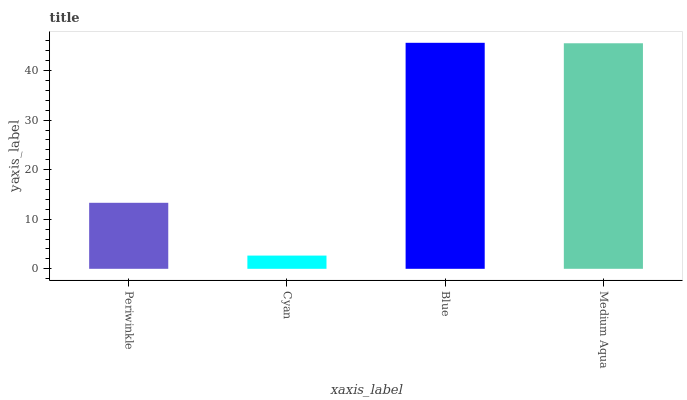Is Cyan the minimum?
Answer yes or no. Yes. Is Blue the maximum?
Answer yes or no. Yes. Is Blue the minimum?
Answer yes or no. No. Is Cyan the maximum?
Answer yes or no. No. Is Blue greater than Cyan?
Answer yes or no. Yes. Is Cyan less than Blue?
Answer yes or no. Yes. Is Cyan greater than Blue?
Answer yes or no. No. Is Blue less than Cyan?
Answer yes or no. No. Is Medium Aqua the high median?
Answer yes or no. Yes. Is Periwinkle the low median?
Answer yes or no. Yes. Is Blue the high median?
Answer yes or no. No. Is Blue the low median?
Answer yes or no. No. 